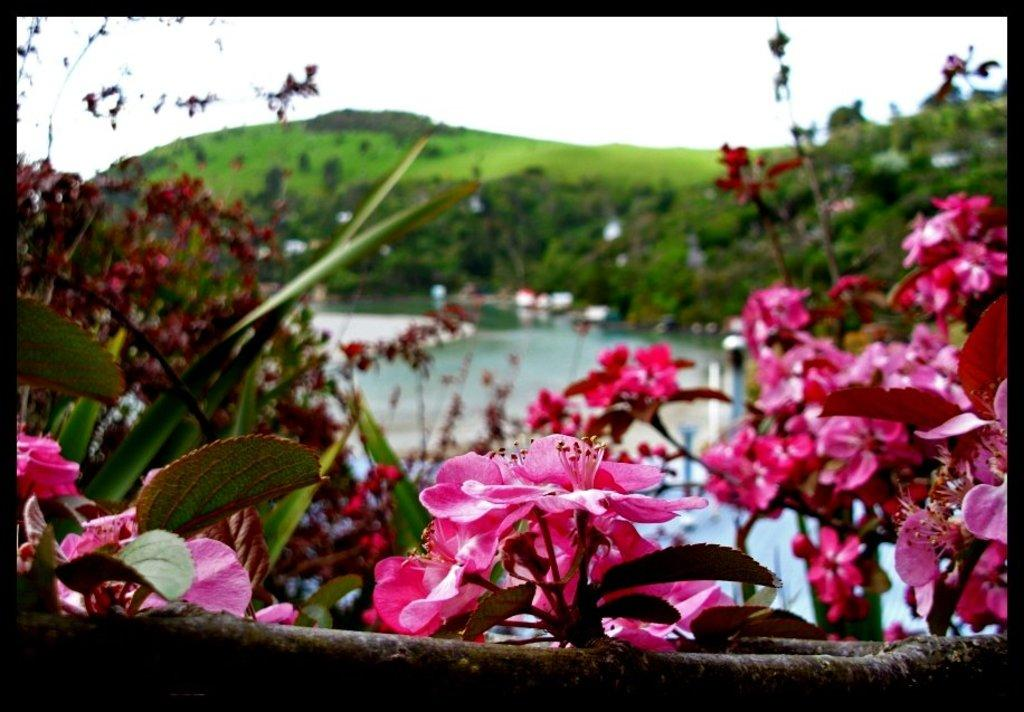What type of vegetation is present in the image? There are trees with flowers in the image. What color are the flowers on the trees? The flowers are pink in color. What can be seen in the distance in the image? There is a hill and water in the background of the image. In which direction does the slope of the hill face in the image? There is no slope mentioned in the image, as it only describes a hill in the background. 